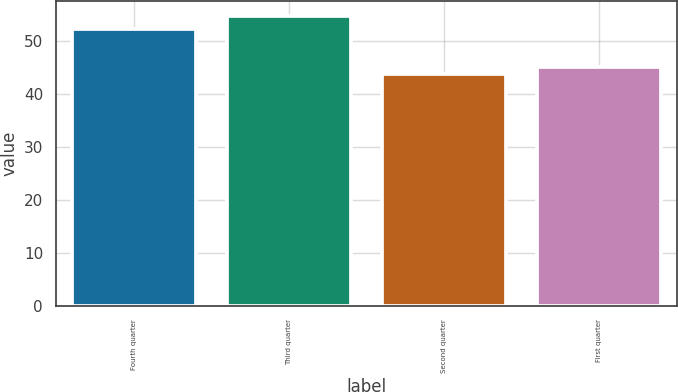<chart> <loc_0><loc_0><loc_500><loc_500><bar_chart><fcel>Fourth quarter<fcel>Third quarter<fcel>Second quarter<fcel>First quarter<nl><fcel>52.3<fcel>54.73<fcel>43.71<fcel>45.05<nl></chart> 